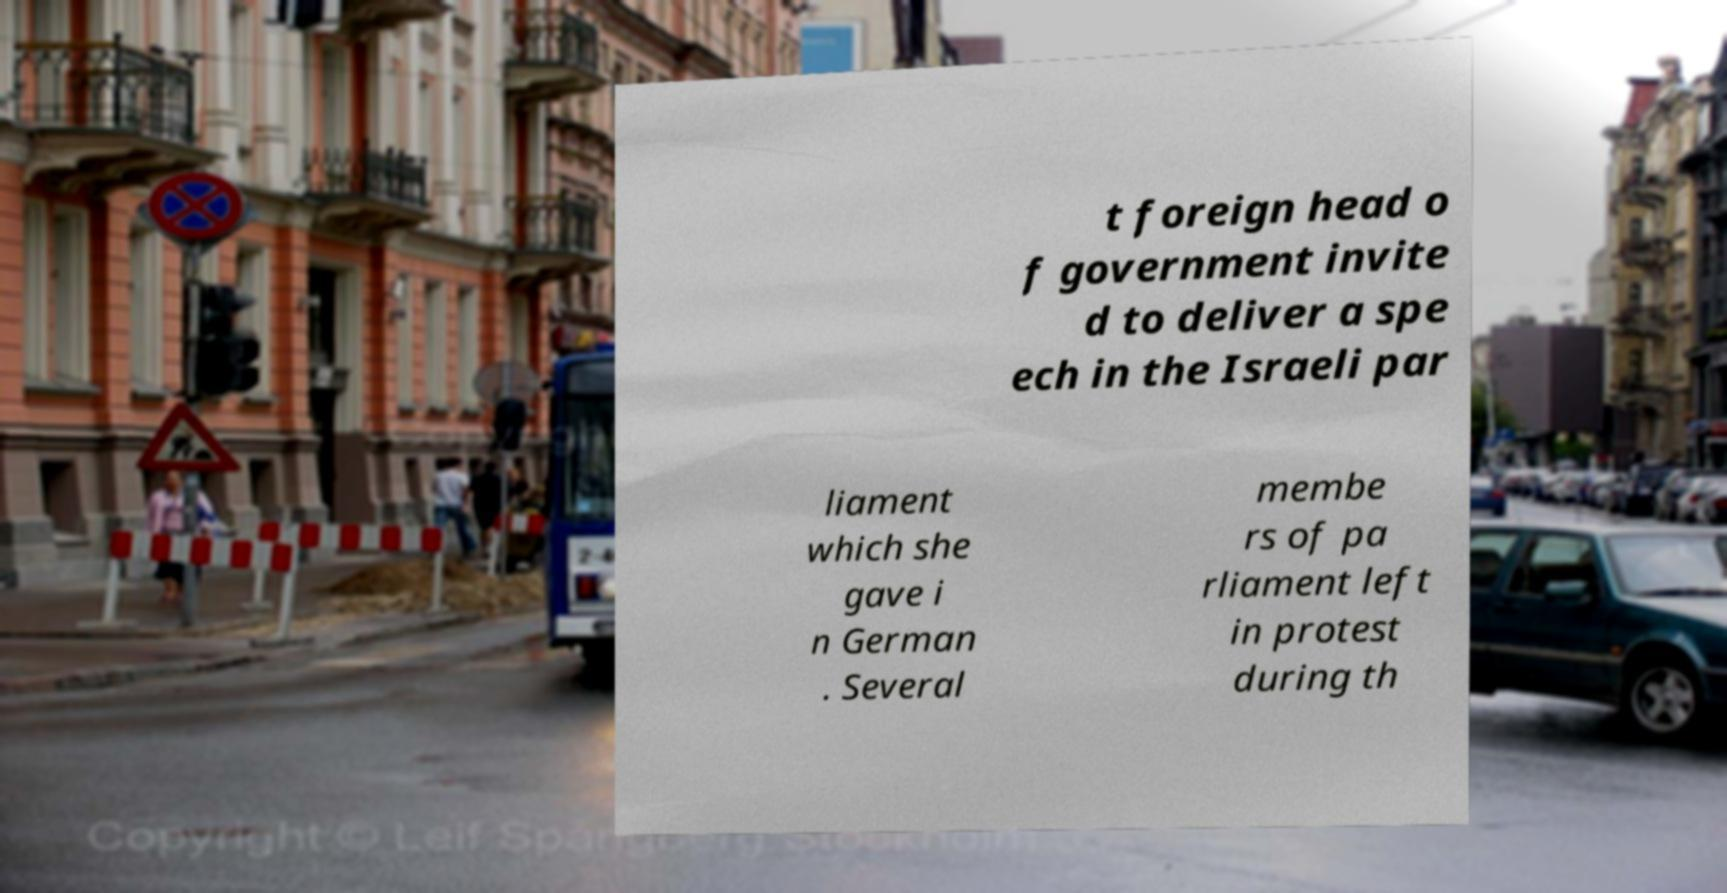What messages or text are displayed in this image? I need them in a readable, typed format. t foreign head o f government invite d to deliver a spe ech in the Israeli par liament which she gave i n German . Several membe rs of pa rliament left in protest during th 